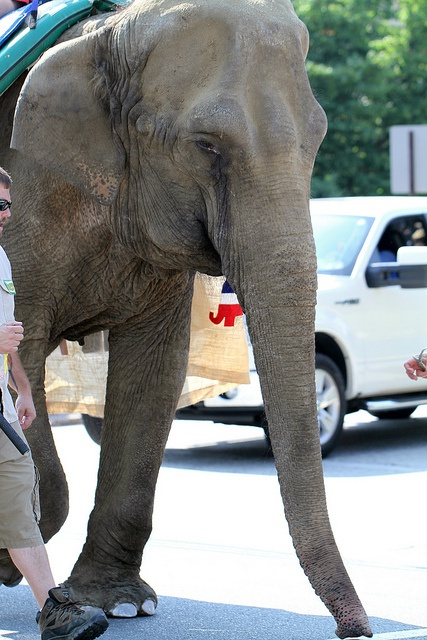Describe the objects in this image and their specific colors. I can see elephant in lavender, gray, black, and darkgray tones, car in lavender, white, black, lightblue, and gray tones, and people in lavender, darkgray, gray, and black tones in this image. 